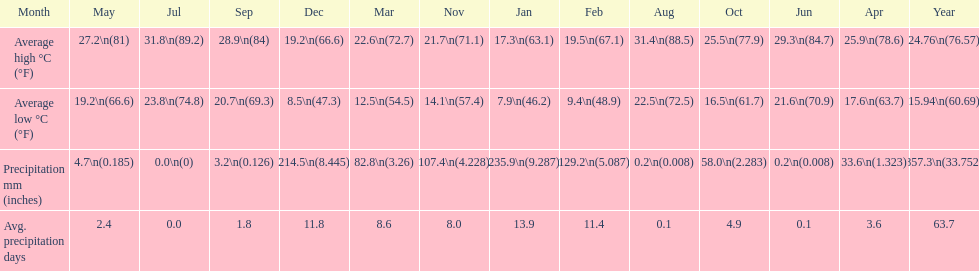Which country is haifa in? Israel. 